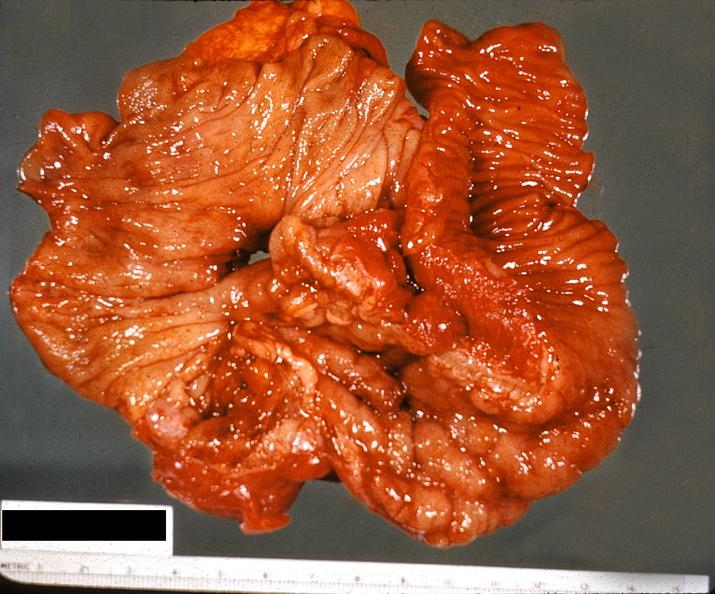s cm present?
Answer the question using a single word or phrase. No 